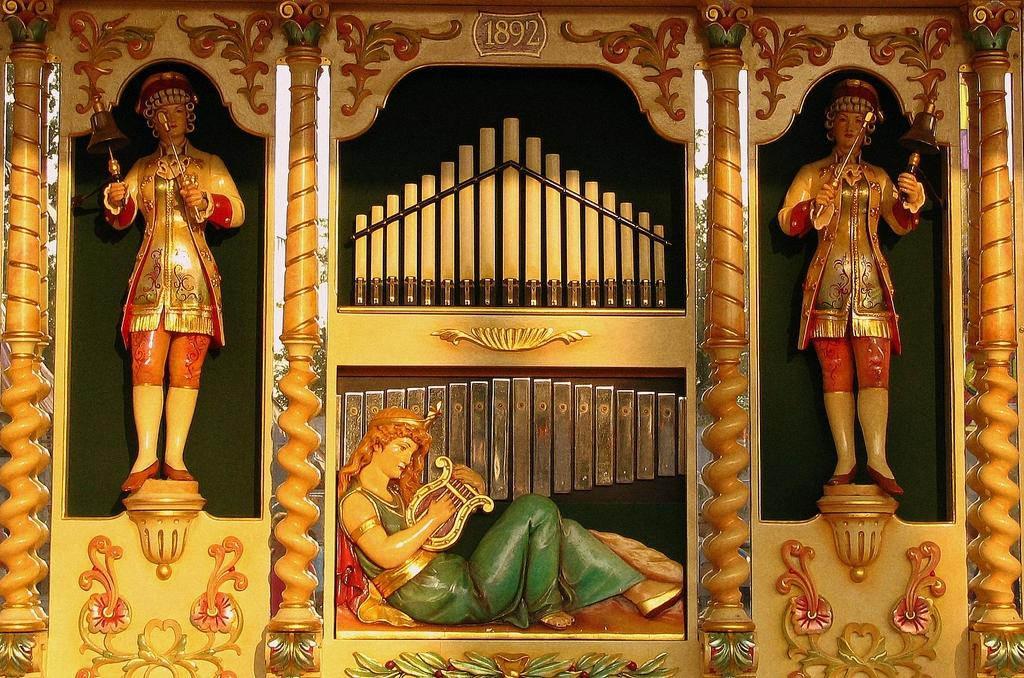What type of art is present in the image? There are sculptures in the image. Can you describe one of the sculptures? One of the sculptures is in the shape of a woman. How many stations are visible in the image? There are no stations present in the image; it features sculptures. What is the value of the flock of birds in the image? There are no birds or flocks present in the image; it features sculptures. 